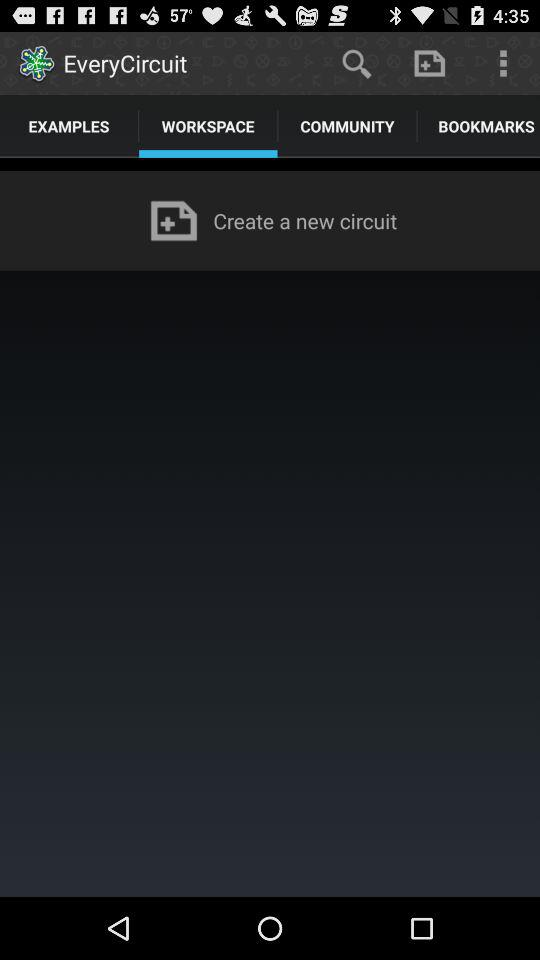Which tab am I using? You are using the "WORKSPACE" tab. 